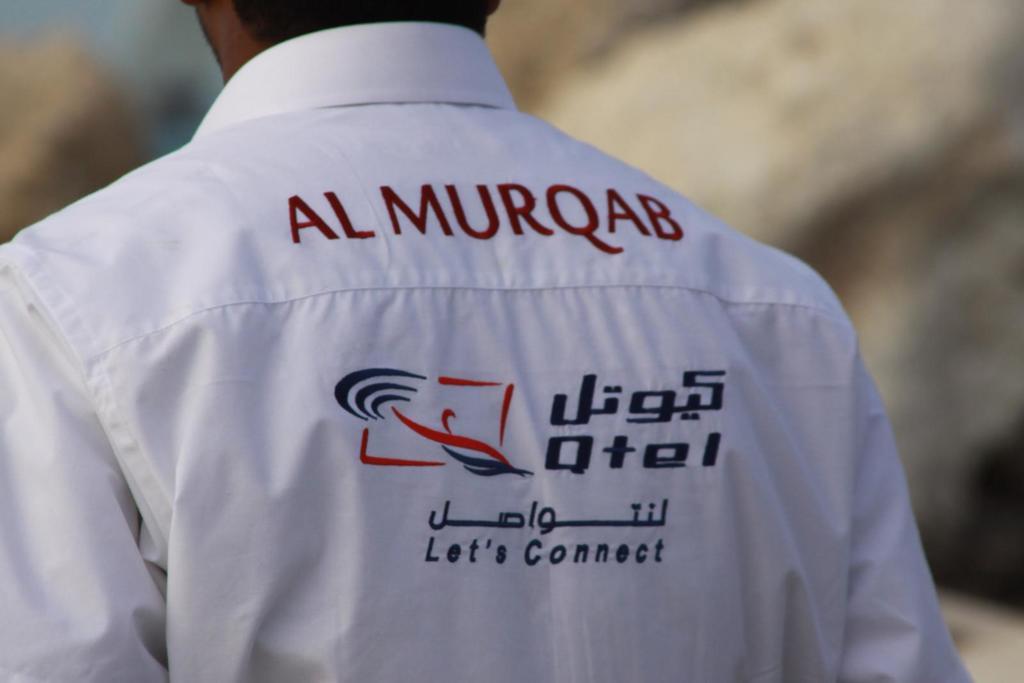What does the last line on this shirt say?
Make the answer very short. Let's connect. 